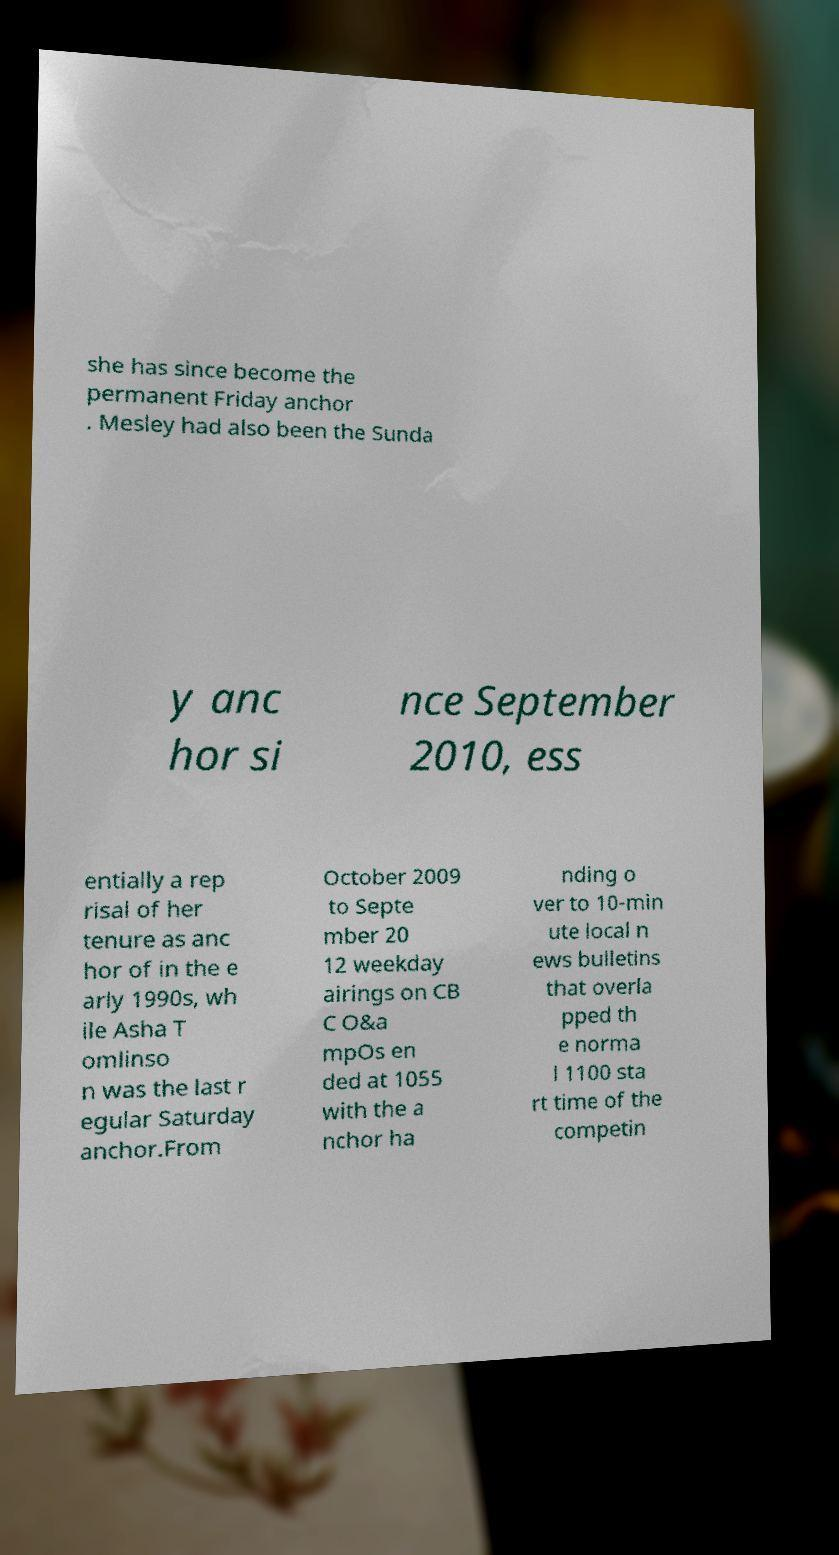I need the written content from this picture converted into text. Can you do that? she has since become the permanent Friday anchor . Mesley had also been the Sunda y anc hor si nce September 2010, ess entially a rep risal of her tenure as anc hor of in the e arly 1990s, wh ile Asha T omlinso n was the last r egular Saturday anchor.From October 2009 to Septe mber 20 12 weekday airings on CB C O&a mpOs en ded at 1055 with the a nchor ha nding o ver to 10-min ute local n ews bulletins that overla pped th e norma l 1100 sta rt time of the competin 